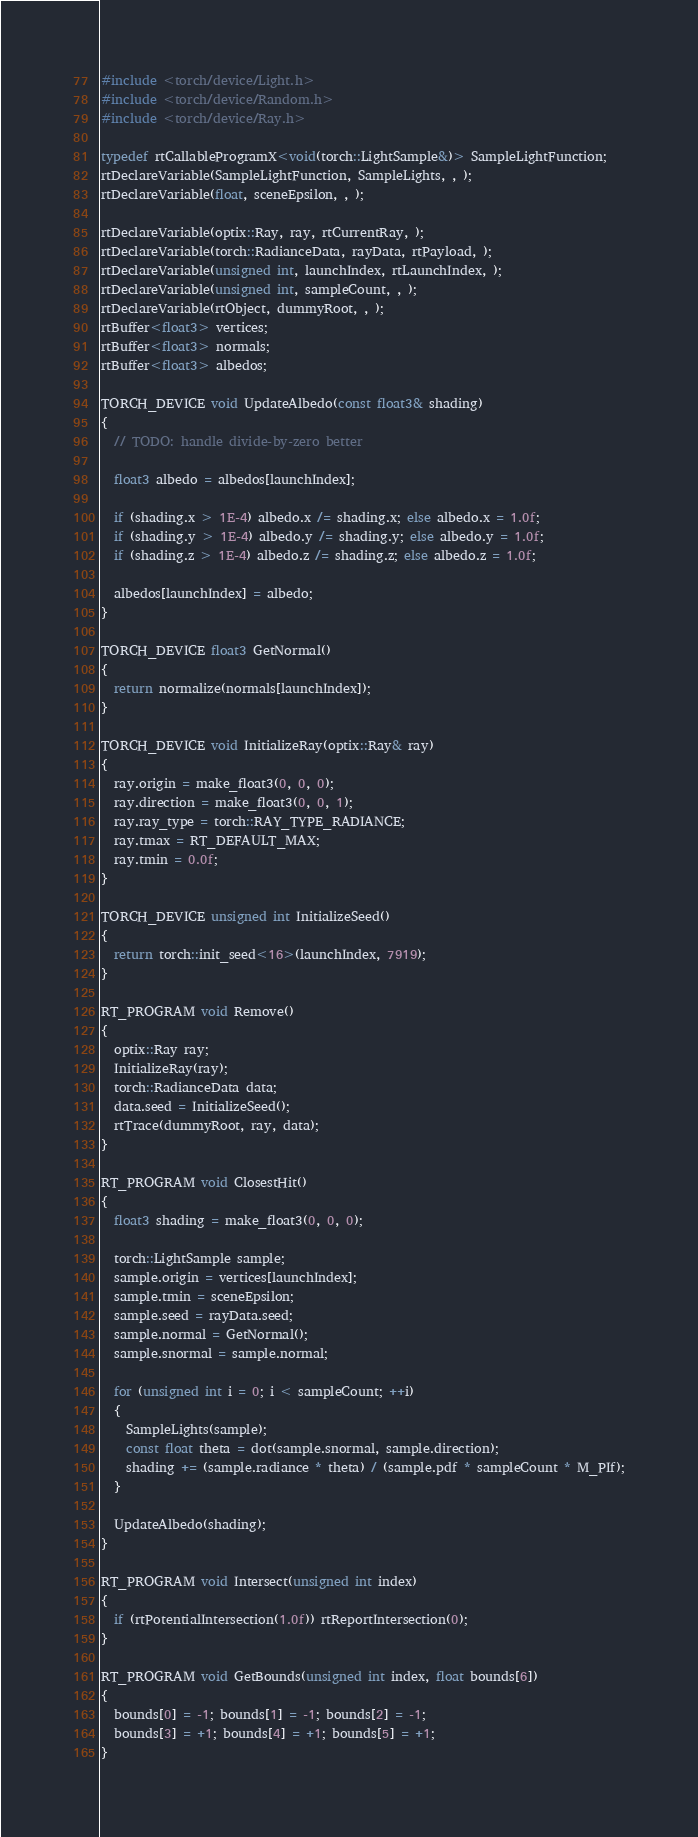Convert code to text. <code><loc_0><loc_0><loc_500><loc_500><_Cuda_>#include <torch/device/Light.h>
#include <torch/device/Random.h>
#include <torch/device/Ray.h>

typedef rtCallableProgramX<void(torch::LightSample&)> SampleLightFunction;
rtDeclareVariable(SampleLightFunction, SampleLights, , );
rtDeclareVariable(float, sceneEpsilon, , );

rtDeclareVariable(optix::Ray, ray, rtCurrentRay, );
rtDeclareVariable(torch::RadianceData, rayData, rtPayload, );
rtDeclareVariable(unsigned int, launchIndex, rtLaunchIndex, );
rtDeclareVariable(unsigned int, sampleCount, , );
rtDeclareVariable(rtObject, dummyRoot, , );
rtBuffer<float3> vertices;
rtBuffer<float3> normals;
rtBuffer<float3> albedos;

TORCH_DEVICE void UpdateAlbedo(const float3& shading)
{
  // TODO: handle divide-by-zero better

  float3 albedo = albedos[launchIndex];

  if (shading.x > 1E-4) albedo.x /= shading.x; else albedo.x = 1.0f;
  if (shading.y > 1E-4) albedo.y /= shading.y; else albedo.y = 1.0f;
  if (shading.z > 1E-4) albedo.z /= shading.z; else albedo.z = 1.0f;

  albedos[launchIndex] = albedo;
}

TORCH_DEVICE float3 GetNormal()
{
  return normalize(normals[launchIndex]);
}

TORCH_DEVICE void InitializeRay(optix::Ray& ray)
{
  ray.origin = make_float3(0, 0, 0);
  ray.direction = make_float3(0, 0, 1);
  ray.ray_type = torch::RAY_TYPE_RADIANCE;
  ray.tmax = RT_DEFAULT_MAX;
  ray.tmin = 0.0f;
}

TORCH_DEVICE unsigned int InitializeSeed()
{
  return torch::init_seed<16>(launchIndex, 7919);
}

RT_PROGRAM void Remove()
{
  optix::Ray ray;
  InitializeRay(ray);
  torch::RadianceData data;
  data.seed = InitializeSeed();
  rtTrace(dummyRoot, ray, data);
}

RT_PROGRAM void ClosestHit()
{
  float3 shading = make_float3(0, 0, 0);

  torch::LightSample sample;
  sample.origin = vertices[launchIndex];
  sample.tmin = sceneEpsilon;
  sample.seed = rayData.seed;
  sample.normal = GetNormal();
  sample.snormal = sample.normal;

  for (unsigned int i = 0; i < sampleCount; ++i)
  {
    SampleLights(sample);
    const float theta = dot(sample.snormal, sample.direction);
    shading += (sample.radiance * theta) / (sample.pdf * sampleCount * M_PIf);
  }

  UpdateAlbedo(shading);
}

RT_PROGRAM void Intersect(unsigned int index)
{
  if (rtPotentialIntersection(1.0f)) rtReportIntersection(0);
}

RT_PROGRAM void GetBounds(unsigned int index, float bounds[6])
{
  bounds[0] = -1; bounds[1] = -1; bounds[2] = -1;
  bounds[3] = +1; bounds[4] = +1; bounds[5] = +1;
}</code> 